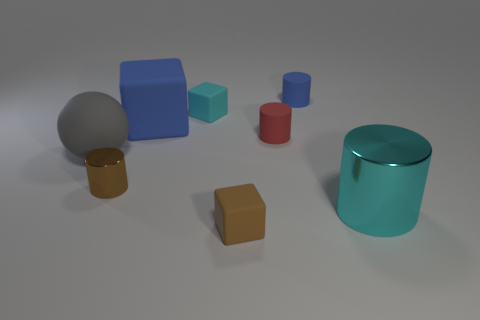Add 1 cyan shiny objects. How many objects exist? 9 Subtract all red matte cylinders. How many cylinders are left? 3 Subtract all spheres. How many objects are left? 7 Subtract 3 cylinders. How many cylinders are left? 1 Subtract all cyan cubes. Subtract all yellow cylinders. How many cubes are left? 2 Subtract all purple blocks. How many brown cylinders are left? 1 Subtract all brown shiny things. Subtract all small rubber objects. How many objects are left? 3 Add 2 brown shiny cylinders. How many brown shiny cylinders are left? 3 Add 4 large green rubber balls. How many large green rubber balls exist? 4 Subtract all blue cylinders. How many cylinders are left? 3 